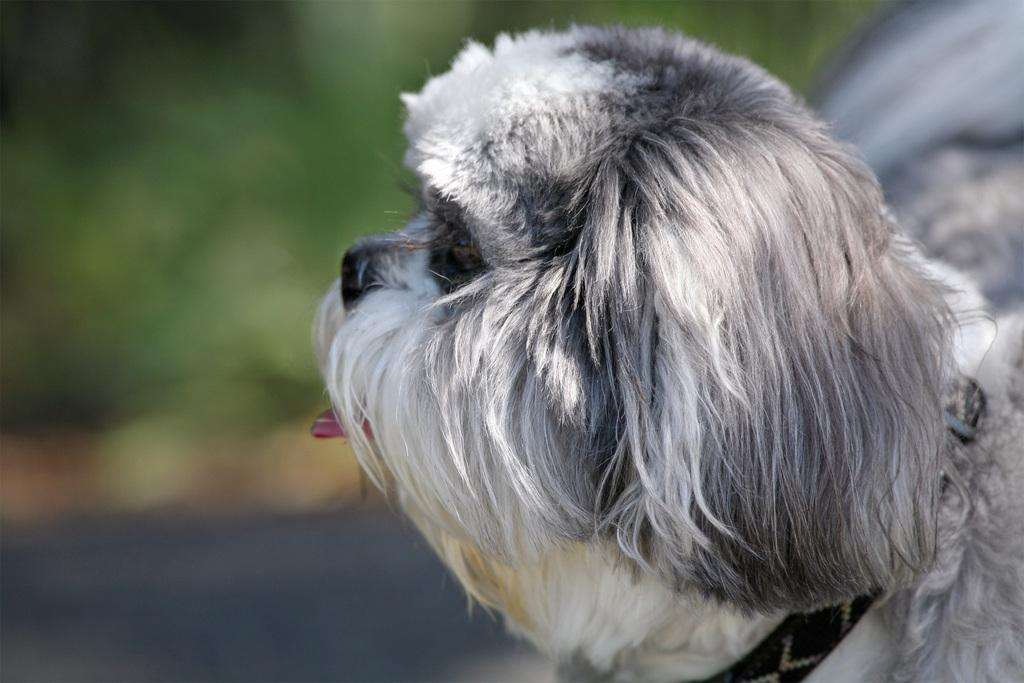What type of animal is in the image? There is a dog in the image. Can you describe the color of the dog? The dog is white and black in color. What is the dog wearing in the image? The dog is wearing a black color belt. What can be seen in the background of the image? There are trees in the background of the image, but they are blurry. What type of meal is being prepared in the playground in the image? There is no meal being prepared in the playground in the image, as there is no playground present. 